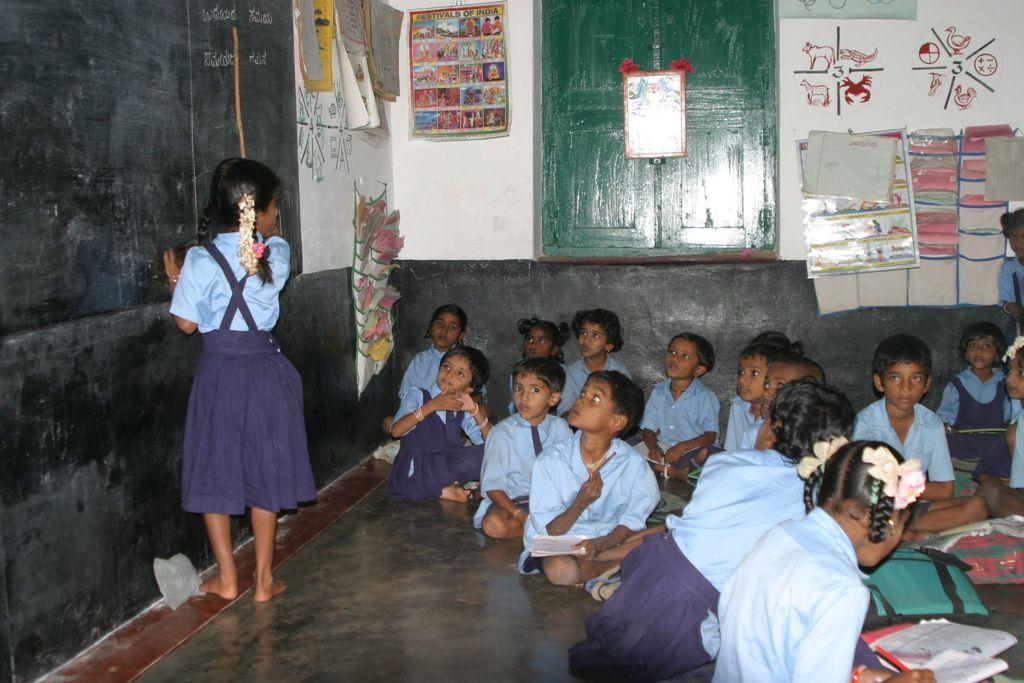What are the children in the image doing? The children in the image are sitting on the floor. Is there any child standing in the image? Yes, there is a child standing in the image. What can be seen in the background of the image? There is a wall, a window, and sheets in the background of the image. What type of produce can be seen on the wall in the image? There is no produce visible on the wall in the image; it only shows a wall, a window, and sheets. 